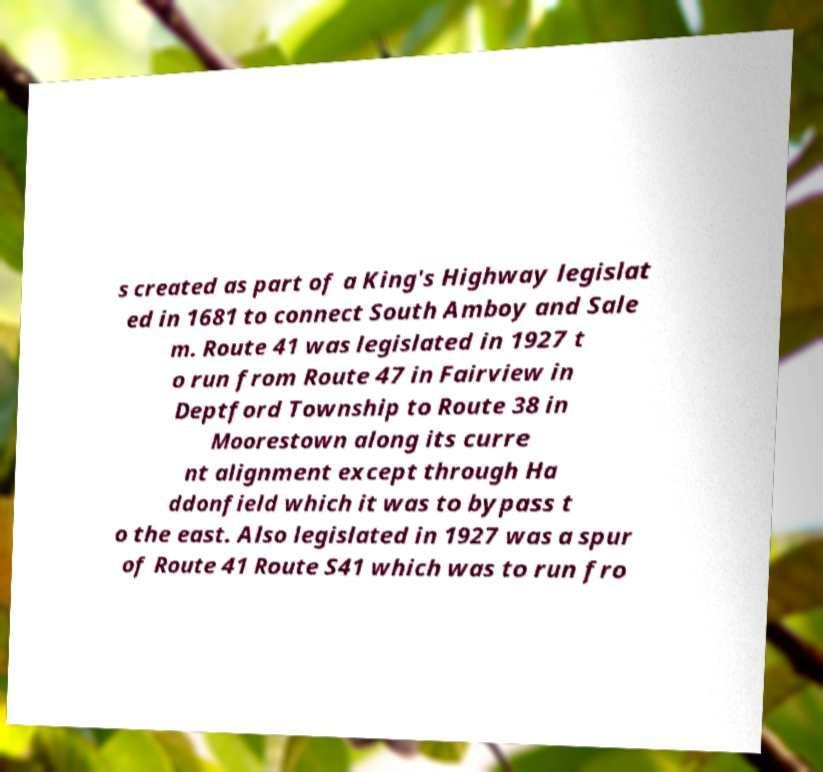Please read and relay the text visible in this image. What does it say? s created as part of a King's Highway legislat ed in 1681 to connect South Amboy and Sale m. Route 41 was legislated in 1927 t o run from Route 47 in Fairview in Deptford Township to Route 38 in Moorestown along its curre nt alignment except through Ha ddonfield which it was to bypass t o the east. Also legislated in 1927 was a spur of Route 41 Route S41 which was to run fro 